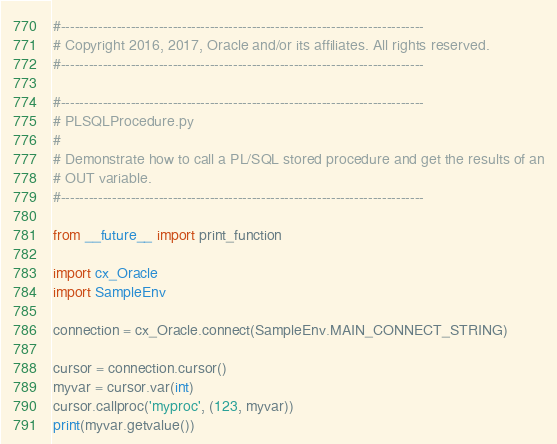Convert code to text. <code><loc_0><loc_0><loc_500><loc_500><_Python_>#------------------------------------------------------------------------------
# Copyright 2016, 2017, Oracle and/or its affiliates. All rights reserved.
#------------------------------------------------------------------------------

#------------------------------------------------------------------------------
# PLSQLProcedure.py
#
# Demonstrate how to call a PL/SQL stored procedure and get the results of an
# OUT variable.
#------------------------------------------------------------------------------

from __future__ import print_function

import cx_Oracle
import SampleEnv

connection = cx_Oracle.connect(SampleEnv.MAIN_CONNECT_STRING)

cursor = connection.cursor()
myvar = cursor.var(int)
cursor.callproc('myproc', (123, myvar))
print(myvar.getvalue())

</code> 